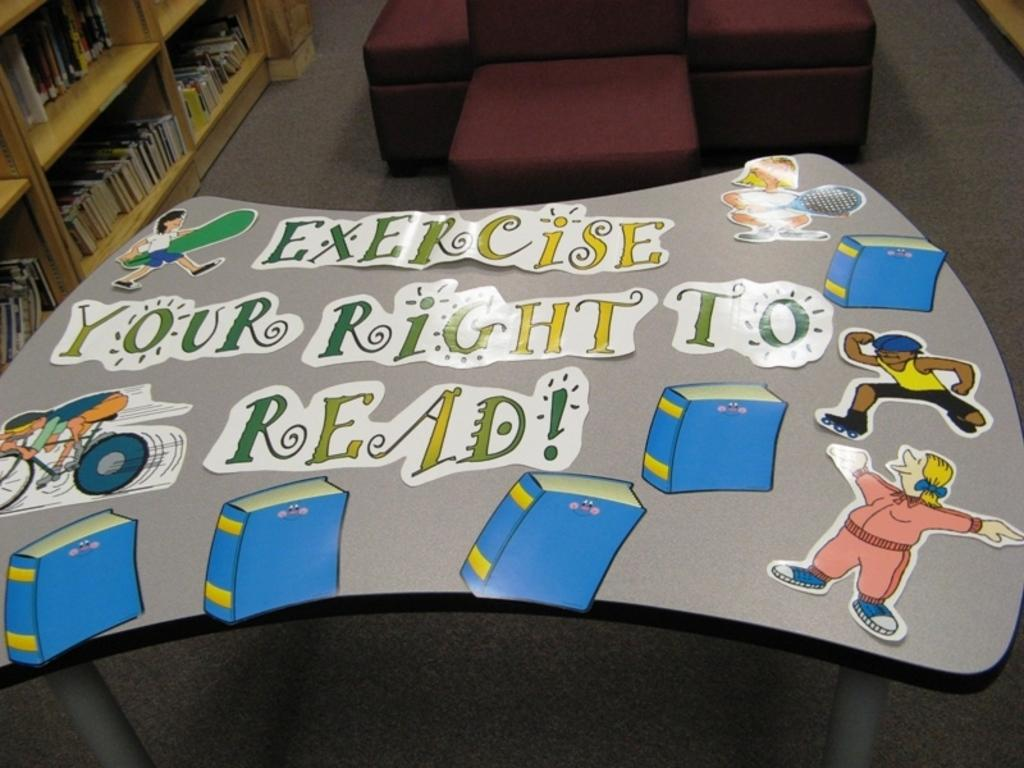Provide a one-sentence caption for the provided image. A kids table in a library is decorated with the slogan exercise your right to read. 